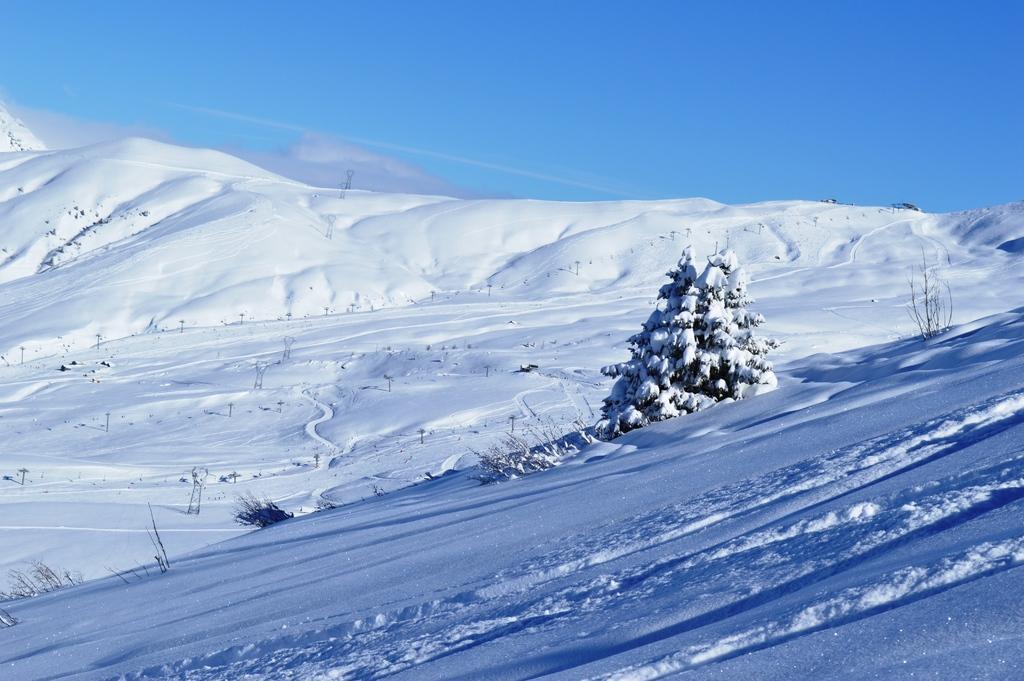Could you give a brief overview of what you see in this image? In this image we can see the tree and the image is fully covered with the snow. Sky is also visible. 